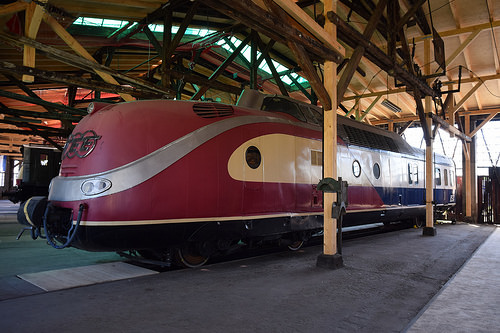<image>
Is the train in front of the post? No. The train is not in front of the post. The spatial positioning shows a different relationship between these objects. 